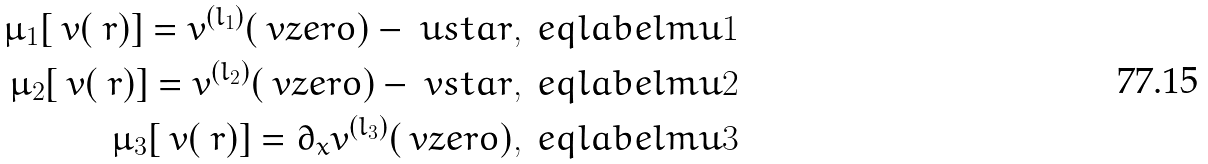<formula> <loc_0><loc_0><loc_500><loc_500>\mu _ { 1 } [ \ v ( \ r ) ] = v ^ { ( l _ { 1 } ) } ( \ v z e r o ) - \ u s t a r , \ e q l a b e l { m u 1 } \\ \mu _ { 2 } [ \ v ( \ r ) ] = v ^ { ( l _ { 2 } ) } ( \ v z e r o ) - \ v s t a r , \ e q l a b e l { m u 2 } \\ \mu _ { 3 } [ \ v ( \ r ) ] = \partial _ { x } v ^ { ( l _ { 3 } ) } ( \ v z e r o ) , \ e q l a b e l { m u 3 }</formula> 